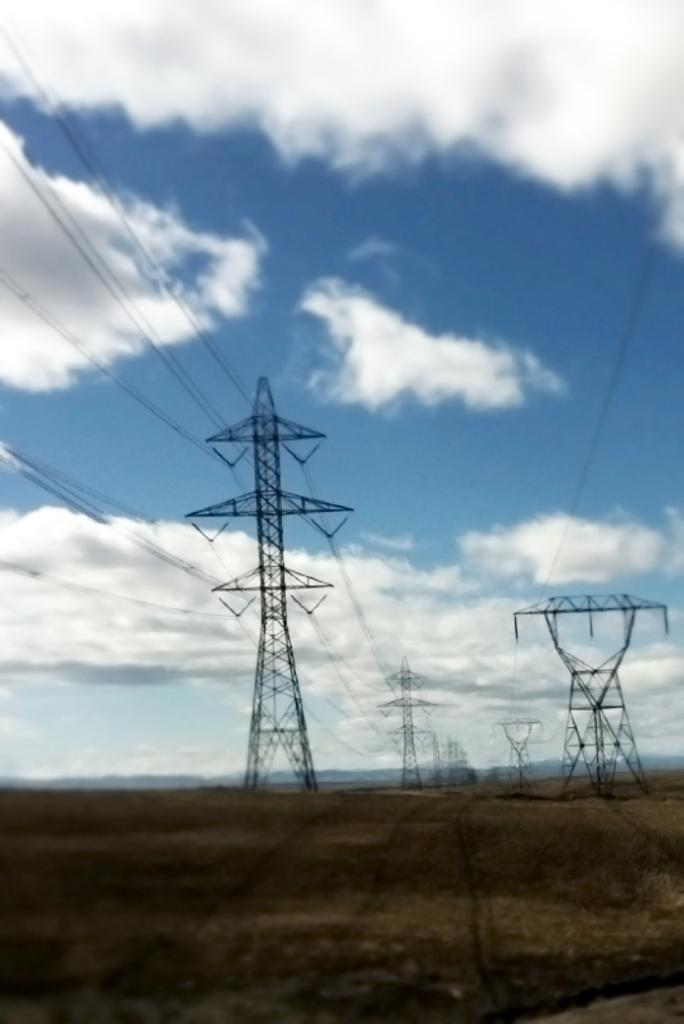What structures are present in the image with wires? There are towers with wires in the image. What can be seen at the base of the image? The ground is visible in the image. What type of landscape feature is present in the image? There are hills in the image. the image. What is visible above the structures and landscape? The sky is visible in the image. How would you describe the weather based on the sky's appearance? The sky appears cloudy in the image. Where is the wound located on the tower in the image? There is no wound present on the tower in the image. What is the middle of the image showing? The image does not have a specific "middle" as it is a photograph and not a composition with a central focus. 